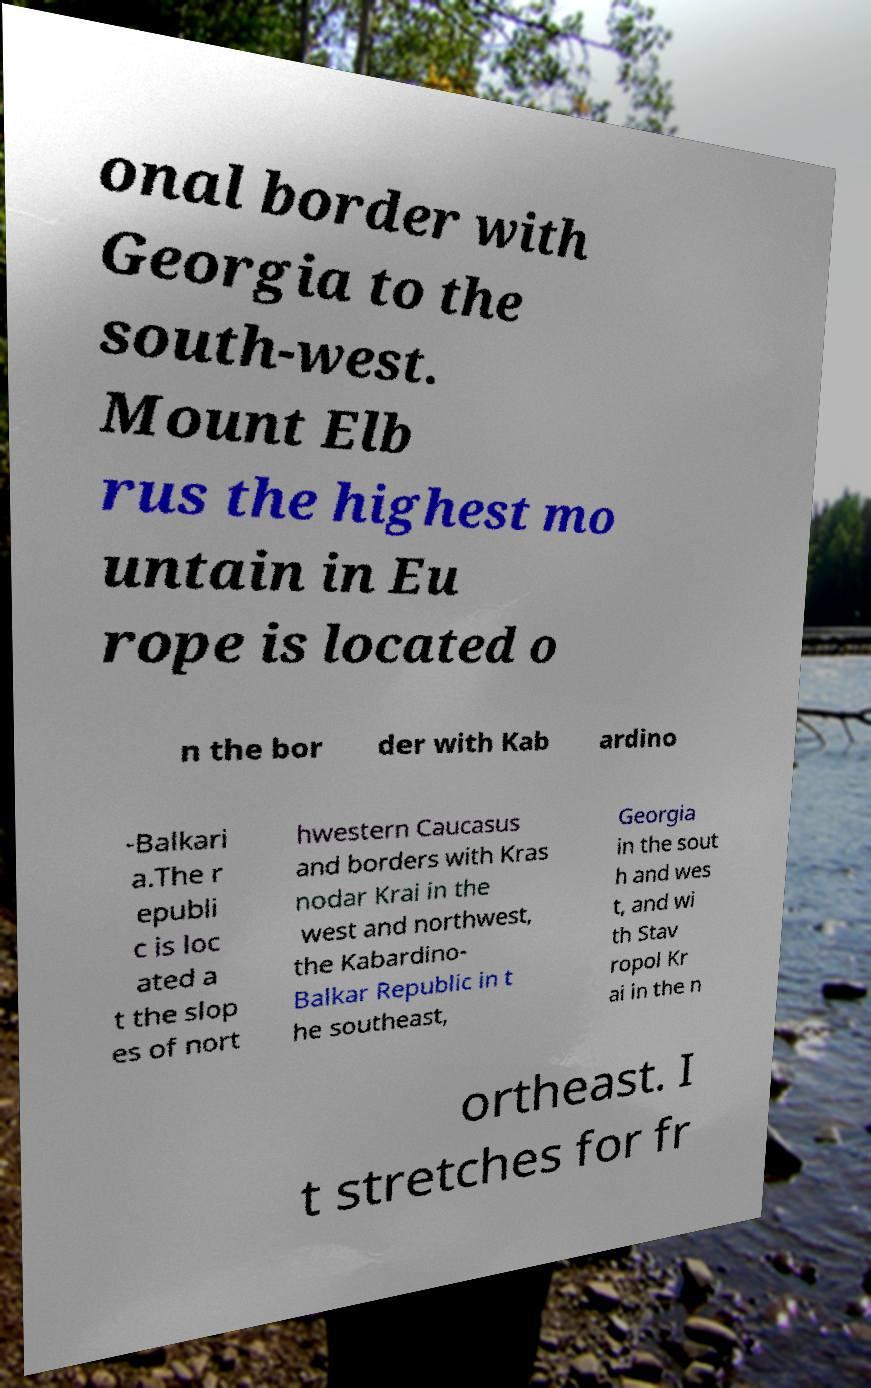Please read and relay the text visible in this image. What does it say? onal border with Georgia to the south-west. Mount Elb rus the highest mo untain in Eu rope is located o n the bor der with Kab ardino -Balkari a.The r epubli c is loc ated a t the slop es of nort hwestern Caucasus and borders with Kras nodar Krai in the west and northwest, the Kabardino- Balkar Republic in t he southeast, Georgia in the sout h and wes t, and wi th Stav ropol Kr ai in the n ortheast. I t stretches for fr 